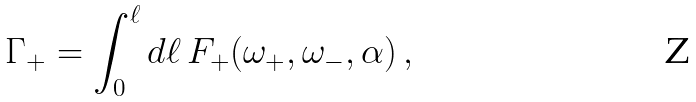<formula> <loc_0><loc_0><loc_500><loc_500>\Gamma _ { + } = \int _ { 0 } ^ { \ell } d \ell \, F _ { + } ( \omega _ { + } , \omega _ { - } , \alpha ) \, ,</formula> 